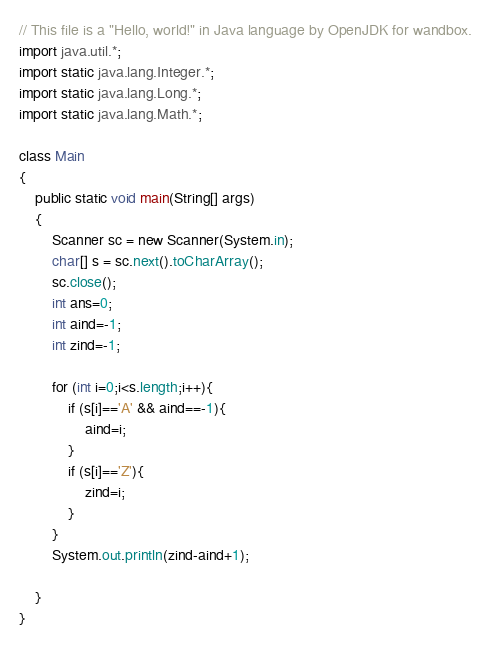Convert code to text. <code><loc_0><loc_0><loc_500><loc_500><_Java_>// This file is a "Hello, world!" in Java language by OpenJDK for wandbox.
import java.util.*;
import static java.lang.Integer.*;
import static java.lang.Long.*;
import static java.lang.Math.*;

class Main
{
    public static void main(String[] args)
    {
        Scanner sc = new Scanner(System.in);
		char[] s = sc.next().toCharArray();
		sc.close();
        int ans=0;
        int aind=-1;
        int zind=-1;
        
        for (int i=0;i<s.length;i++){
            if (s[i]=='A' && aind==-1){
                aind=i;
            }    
            if (s[i]=='Z'){
                zind=i;
            }
        }
		System.out.println(zind-aind+1);        
    
    }
}

</code> 